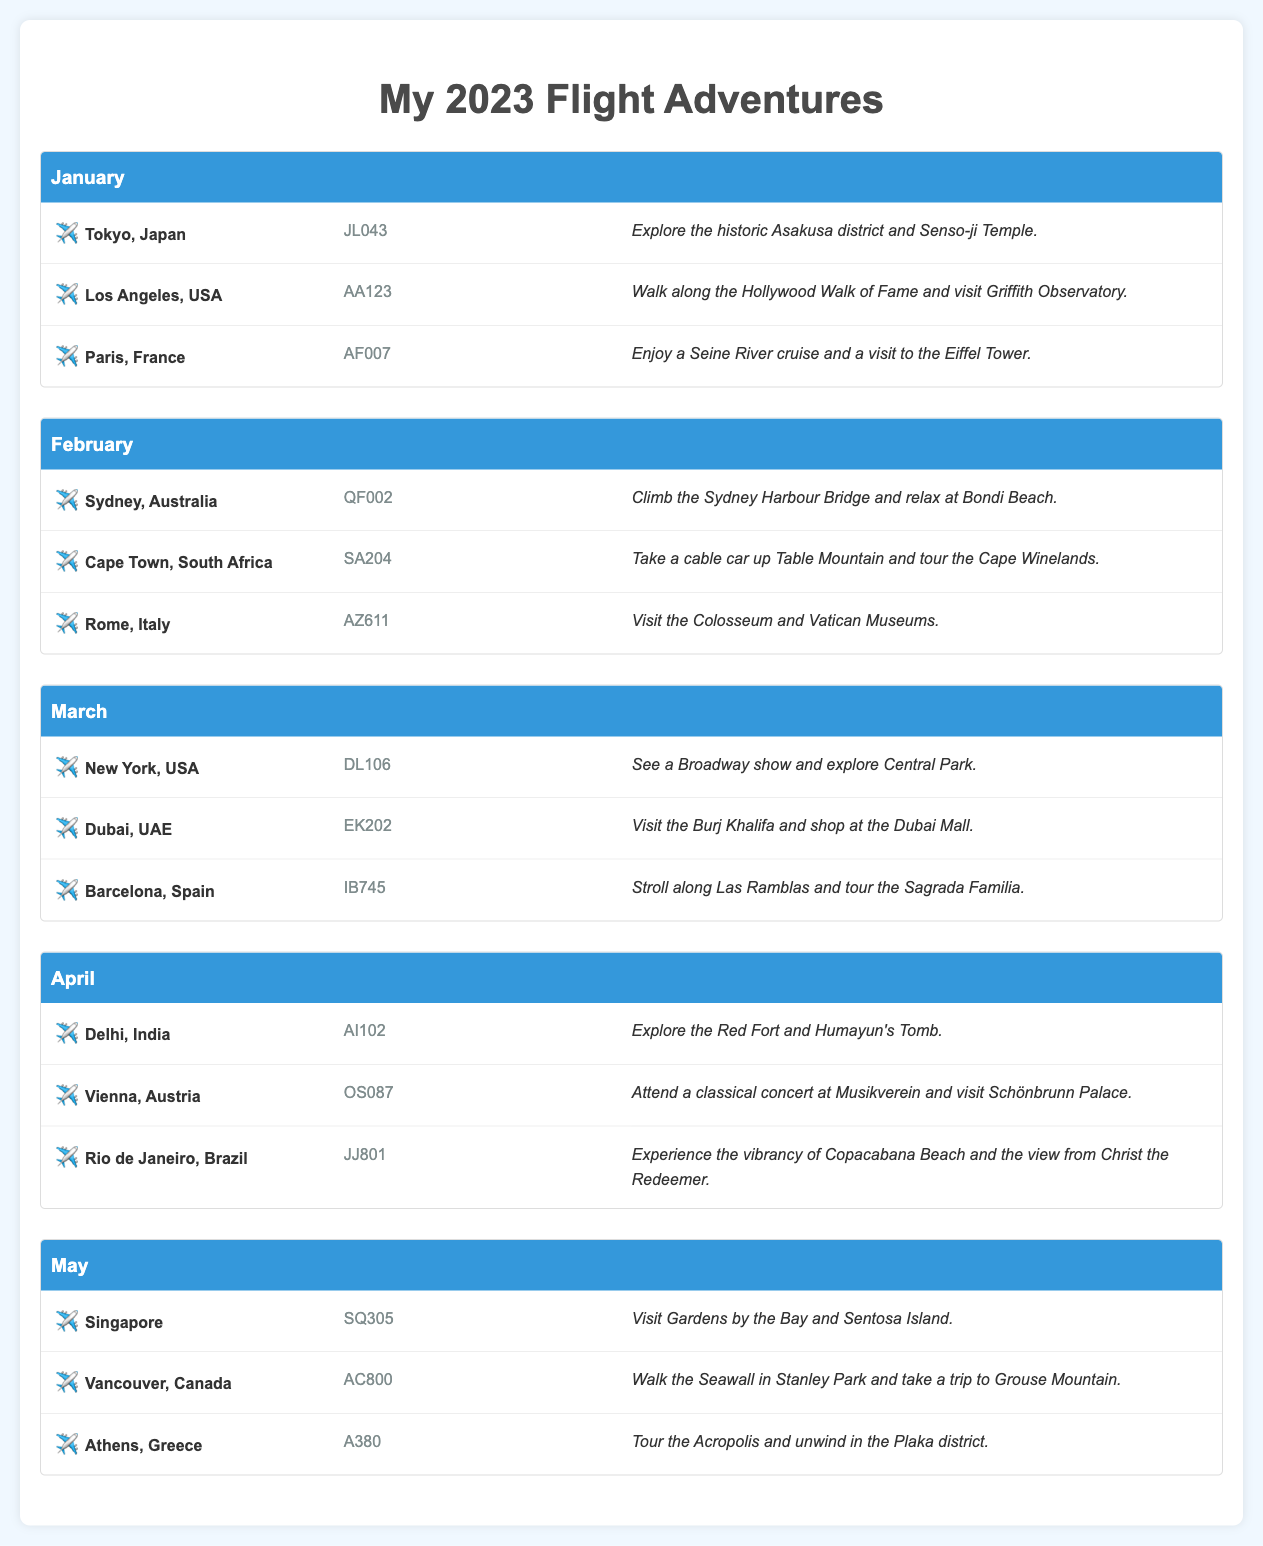What destinations are featured in January? The destinations listed in January are Tokyo, Los Angeles, and Paris.
Answer: Tokyo, Los Angeles, Paris How many flights are scheduled for February? There are three flights listed for February, all with different destinations.
Answer: 3 What is the flight number for the Sydney flight? The flight number for the Sydney flight in February is QF002.
Answer: QF002 Which month features a flight to Delhi, India? The month that includes a flight to Delhi is April.
Answer: April What experience is highlighted for the Paris destination? The highlighted experience for Paris is enjoying a Seine River cruise and visiting the Eiffel Tower.
Answer: Enjoy a Seine River cruise and a visit to the Eiffel Tower Which city is associated with the flight number DL106? The flight number DL106 is associated with New York, USA.
Answer: New York, USA How many different countries are represented in the document? The document features various countries across different months, totaling fourteen distinct countries.
Answer: 14 What was the experience in Rio de Janeiro? The experience highlighted in Rio de Janeiro is experiencing the vibrancy of Copacabana Beach and the view from Christ the Redeemer.
Answer: Experience the vibrancy of Copacabana Beach and the view from Christ the Redeemer What activity can you do in Cape Town, South Africa? In Cape Town, it's noted to take a cable car up Table Mountain and tour the Cape Winelands.
Answer: Take a cable car up Table Mountain and tour the Cape Winelands 